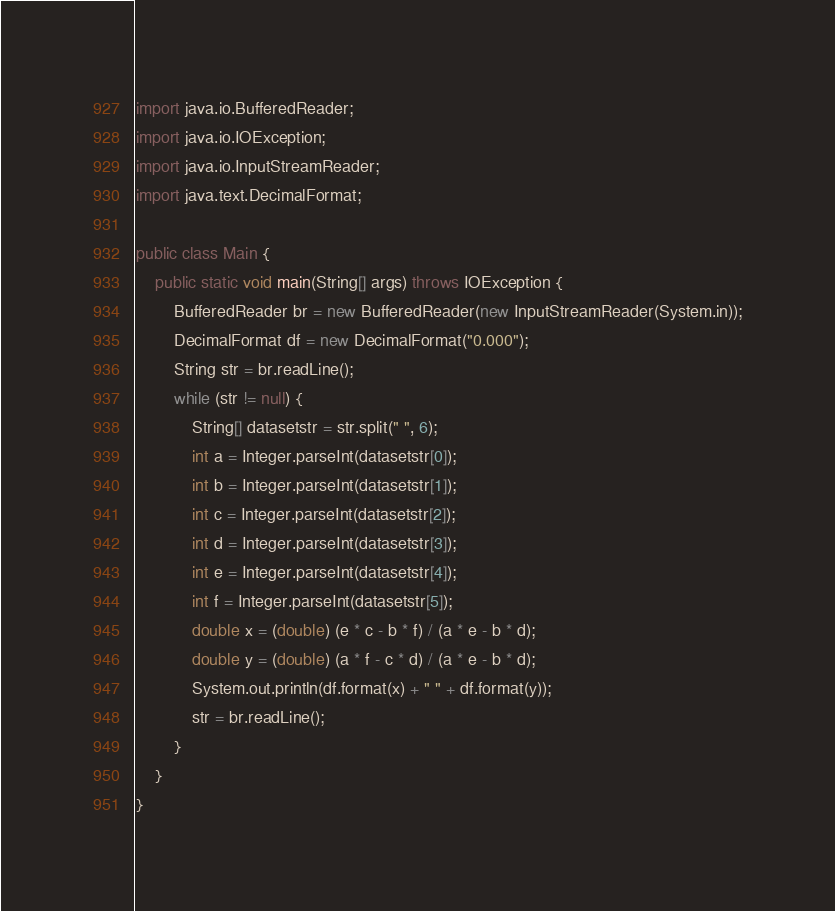Convert code to text. <code><loc_0><loc_0><loc_500><loc_500><_Java_>import java.io.BufferedReader;
import java.io.IOException;
import java.io.InputStreamReader;
import java.text.DecimalFormat;

public class Main {
	public static void main(String[] args) throws IOException {
		BufferedReader br = new BufferedReader(new InputStreamReader(System.in));
		DecimalFormat df = new DecimalFormat("0.000");
		String str = br.readLine();
		while (str != null) {
			String[] datasetstr = str.split(" ", 6);
			int a = Integer.parseInt(datasetstr[0]);
			int b = Integer.parseInt(datasetstr[1]);
			int c = Integer.parseInt(datasetstr[2]);
			int d = Integer.parseInt(datasetstr[3]);
			int e = Integer.parseInt(datasetstr[4]);
			int f = Integer.parseInt(datasetstr[5]);
			double x = (double) (e * c - b * f) / (a * e - b * d);
			double y = (double) (a * f - c * d) / (a * e - b * d);
			System.out.println(df.format(x) + " " + df.format(y));
			str = br.readLine();
		}
	}
}</code> 